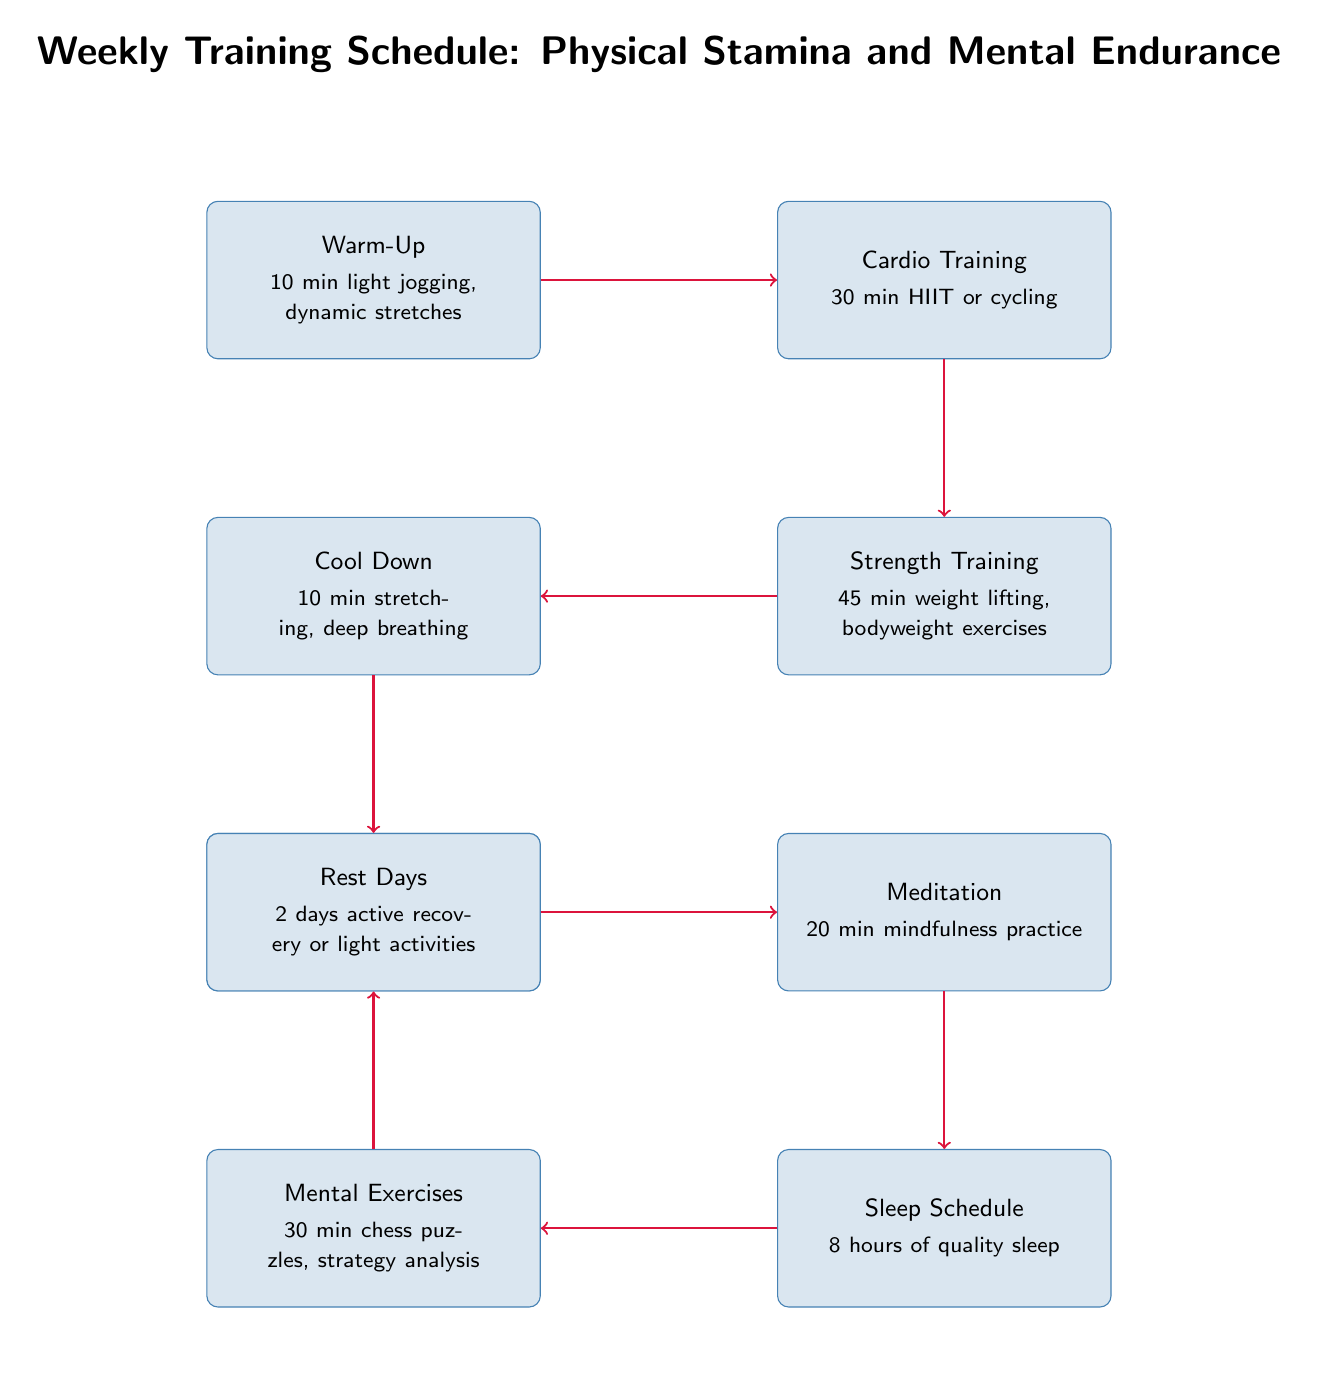What is the duration of the Warm-Up? The Warm-Up node indicates a duration of "10 min" for the activity, as explicitly stated in the diagram.
Answer: 10 min How many mental exercises are scheduled? The Mental Exercises node details a scheduled time of "30 min" for this activity, which defines its duration.
Answer: 30 min What follows the Cardio Training in the schedule? The arrow indicates that the next node after Cardio Training is Strength Training, demonstrating the progression in the training plan.
Answer: Strength Training How many nodes are there in total? By counting the boxes representing different activities, the total number of nodes in the diagram is eight, including all training and recovery elements.
Answer: 8 What is the first activity in the training schedule? According to the flow of the diagram, the first activity listed is the Warm-Up, as it is positioned at the top of the diagram sequence.
Answer: Warm-Up What is the relationship between Sleep Schedule and Meditation? The diagram shows a direct arrow flowing from Meditation to Sleep Schedule, indicating that meditation is a step leading into the sleep schedule.
Answer: Meditation to Sleep Schedule Is there a Cool Down activity? The diagram includes a Cool Down node, which explicitly indicates that this is part of the training schedule, confirming its presence.
Answer: Yes Which two activities are aimed at mental endurance? The diagram includes both Meditation and Mental Exercises as targeted activities focused on enhancing mental endurance.
Answer: Meditation and Mental Exercises What is the purpose of the Rest Days in the training schedule? The Rest Days node suggests "active recovery or light activities," serving the purpose of allowing the body to recover while maintaining light engagement.
Answer: Active recovery or light activities 